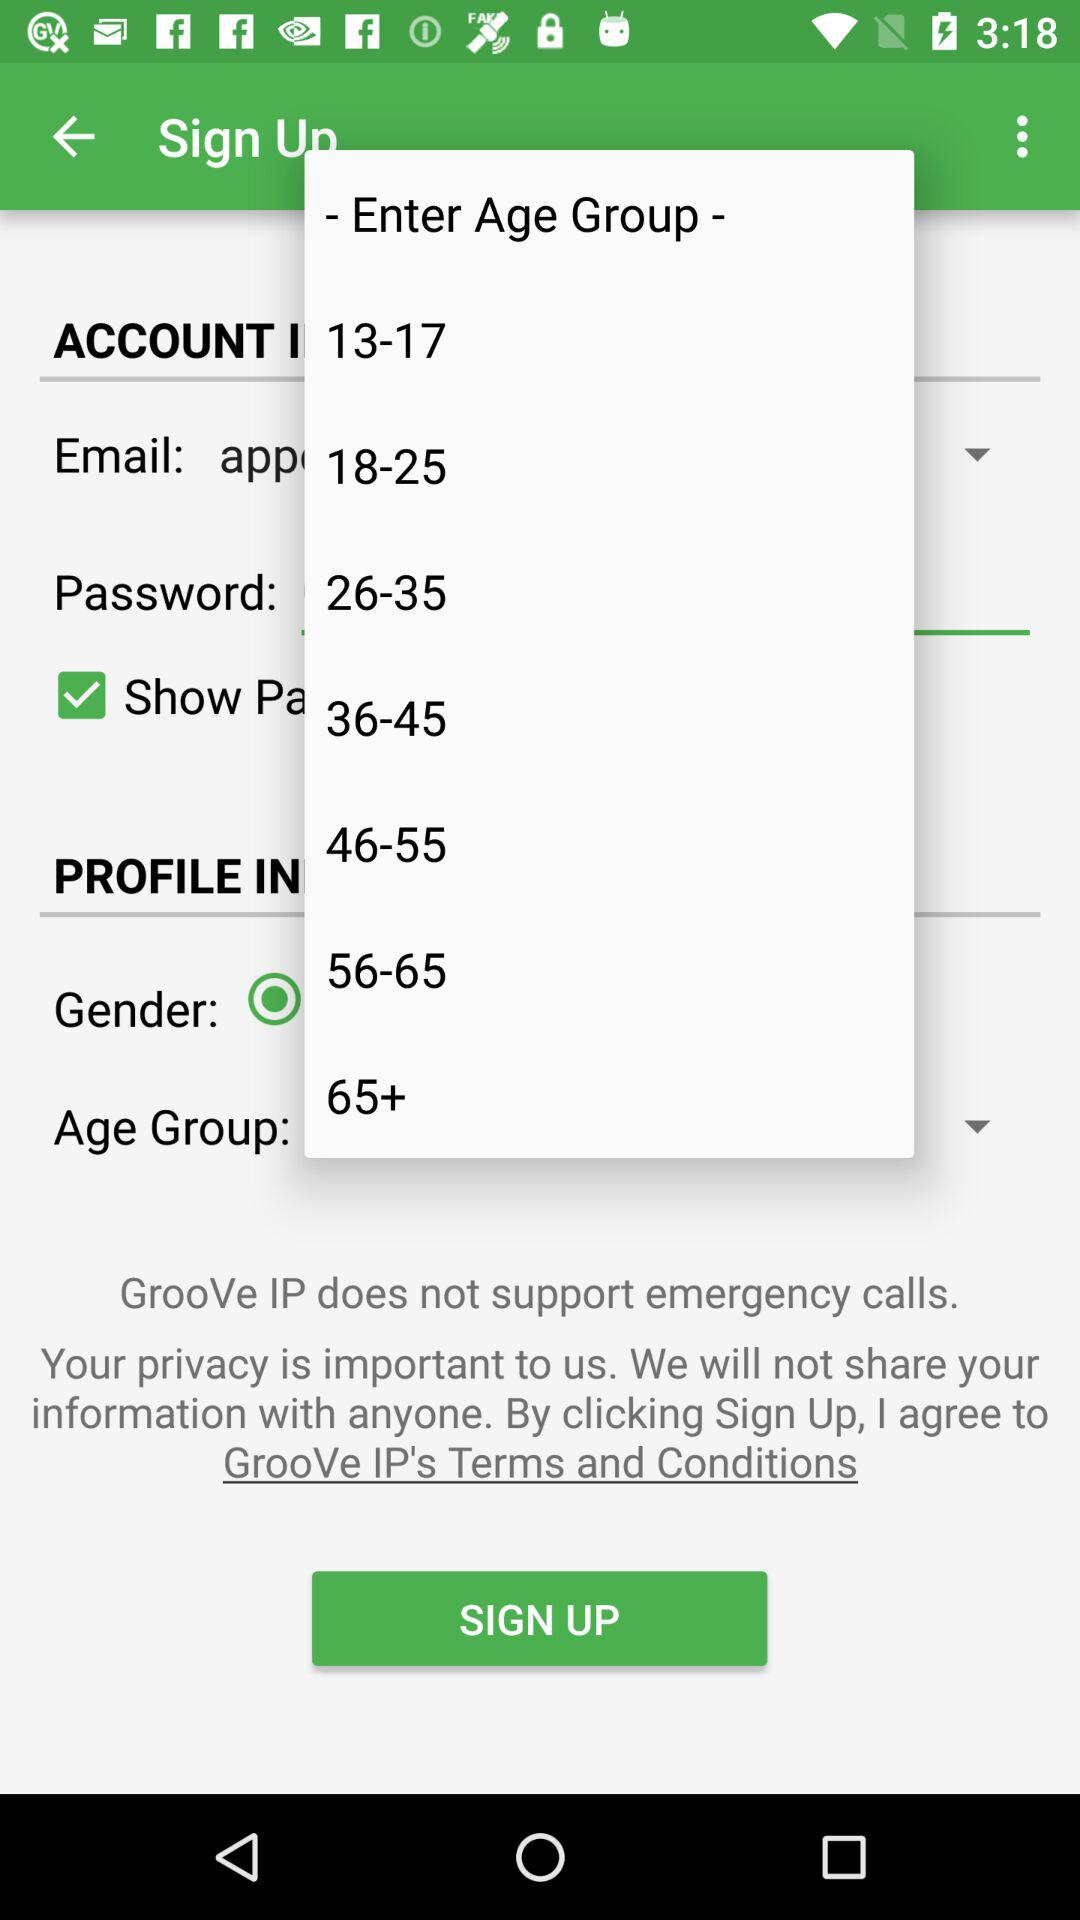What is the status of show password?
When the provided information is insufficient, respond with <no answer>. <no answer> 